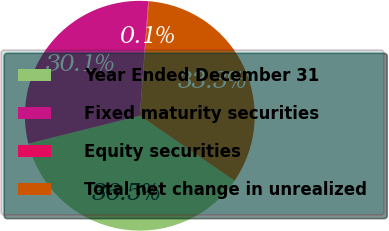Convert chart. <chart><loc_0><loc_0><loc_500><loc_500><pie_chart><fcel>Year Ended December 31<fcel>Fixed maturity securities<fcel>Equity securities<fcel>Total net change in unrealized<nl><fcel>36.53%<fcel>30.08%<fcel>0.08%<fcel>33.31%<nl></chart> 